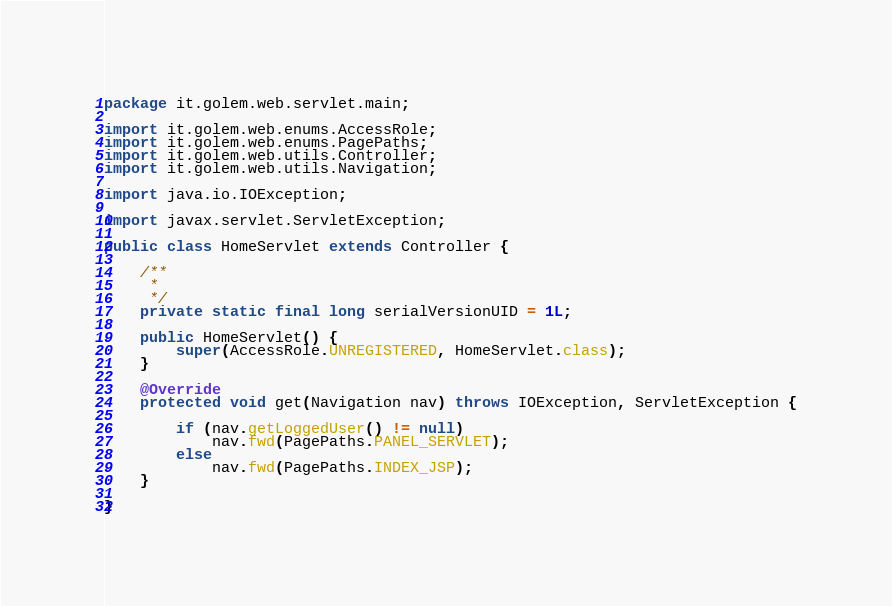Convert code to text. <code><loc_0><loc_0><loc_500><loc_500><_Java_>package it.golem.web.servlet.main;

import it.golem.web.enums.AccessRole;
import it.golem.web.enums.PagePaths;
import it.golem.web.utils.Controller;
import it.golem.web.utils.Navigation;

import java.io.IOException;

import javax.servlet.ServletException;

public class HomeServlet extends Controller {

	/**
	 * 
	 */
	private static final long serialVersionUID = 1L;

	public HomeServlet() {
		super(AccessRole.UNREGISTERED, HomeServlet.class);
	}

	@Override
	protected void get(Navigation nav) throws IOException, ServletException {

		if (nav.getLoggedUser() != null)
			nav.fwd(PagePaths.PANEL_SERVLET);
		else
			nav.fwd(PagePaths.INDEX_JSP);
	}

}
</code> 